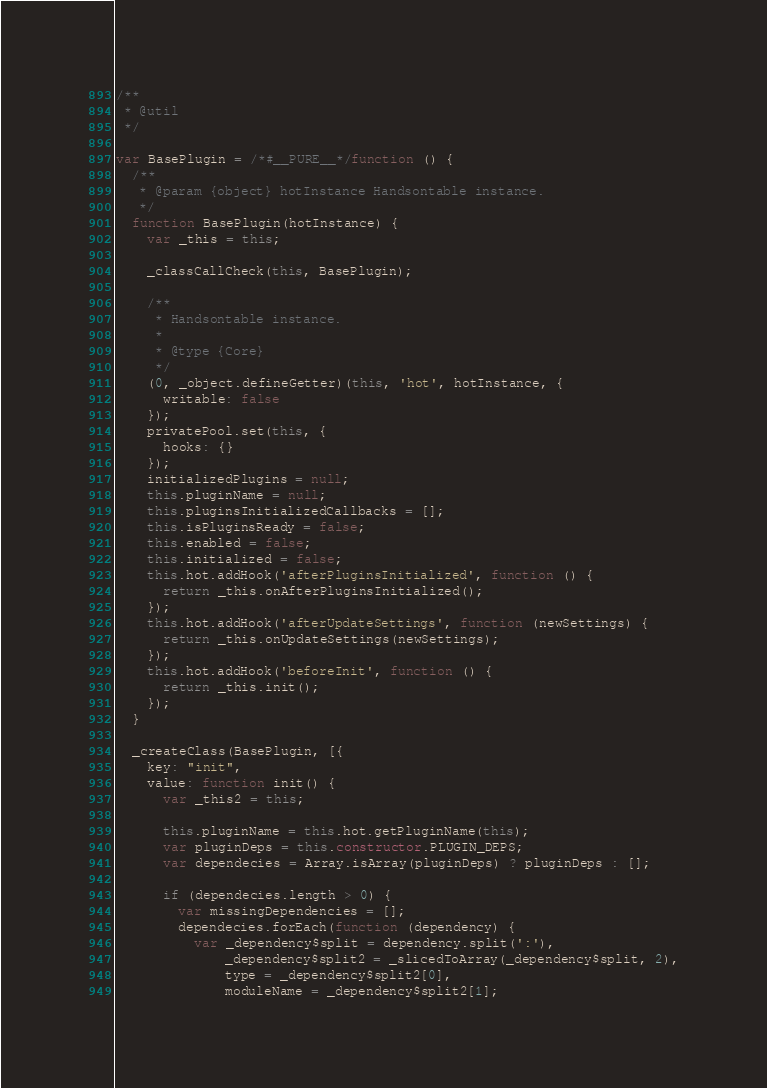<code> <loc_0><loc_0><loc_500><loc_500><_JavaScript_>/**
 * @util
 */

var BasePlugin = /*#__PURE__*/function () {
  /**
   * @param {object} hotInstance Handsontable instance.
   */
  function BasePlugin(hotInstance) {
    var _this = this;

    _classCallCheck(this, BasePlugin);

    /**
     * Handsontable instance.
     *
     * @type {Core}
     */
    (0, _object.defineGetter)(this, 'hot', hotInstance, {
      writable: false
    });
    privatePool.set(this, {
      hooks: {}
    });
    initializedPlugins = null;
    this.pluginName = null;
    this.pluginsInitializedCallbacks = [];
    this.isPluginsReady = false;
    this.enabled = false;
    this.initialized = false;
    this.hot.addHook('afterPluginsInitialized', function () {
      return _this.onAfterPluginsInitialized();
    });
    this.hot.addHook('afterUpdateSettings', function (newSettings) {
      return _this.onUpdateSettings(newSettings);
    });
    this.hot.addHook('beforeInit', function () {
      return _this.init();
    });
  }

  _createClass(BasePlugin, [{
    key: "init",
    value: function init() {
      var _this2 = this;

      this.pluginName = this.hot.getPluginName(this);
      var pluginDeps = this.constructor.PLUGIN_DEPS;
      var dependecies = Array.isArray(pluginDeps) ? pluginDeps : [];

      if (dependecies.length > 0) {
        var missingDependencies = [];
        dependecies.forEach(function (dependency) {
          var _dependency$split = dependency.split(':'),
              _dependency$split2 = _slicedToArray(_dependency$split, 2),
              type = _dependency$split2[0],
              moduleName = _dependency$split2[1];
</code> 